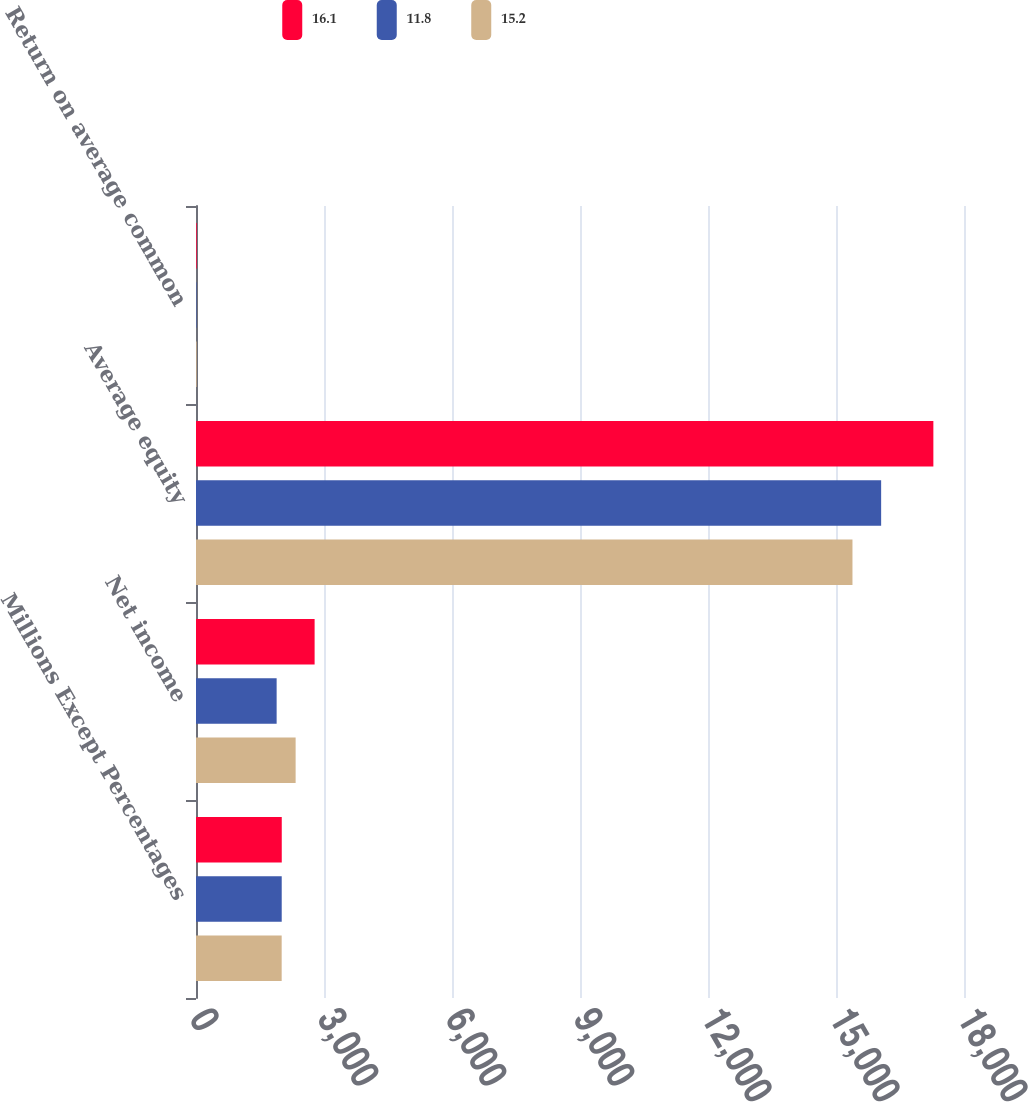Convert chart to OTSL. <chart><loc_0><loc_0><loc_500><loc_500><stacked_bar_chart><ecel><fcel>Millions Except Percentages<fcel>Net income<fcel>Average equity<fcel>Return on average common<nl><fcel>16.1<fcel>2010<fcel>2780<fcel>17282<fcel>16.1<nl><fcel>11.8<fcel>2009<fcel>1890<fcel>16058<fcel>11.8<nl><fcel>15.2<fcel>2008<fcel>2335<fcel>15386<fcel>15.2<nl></chart> 